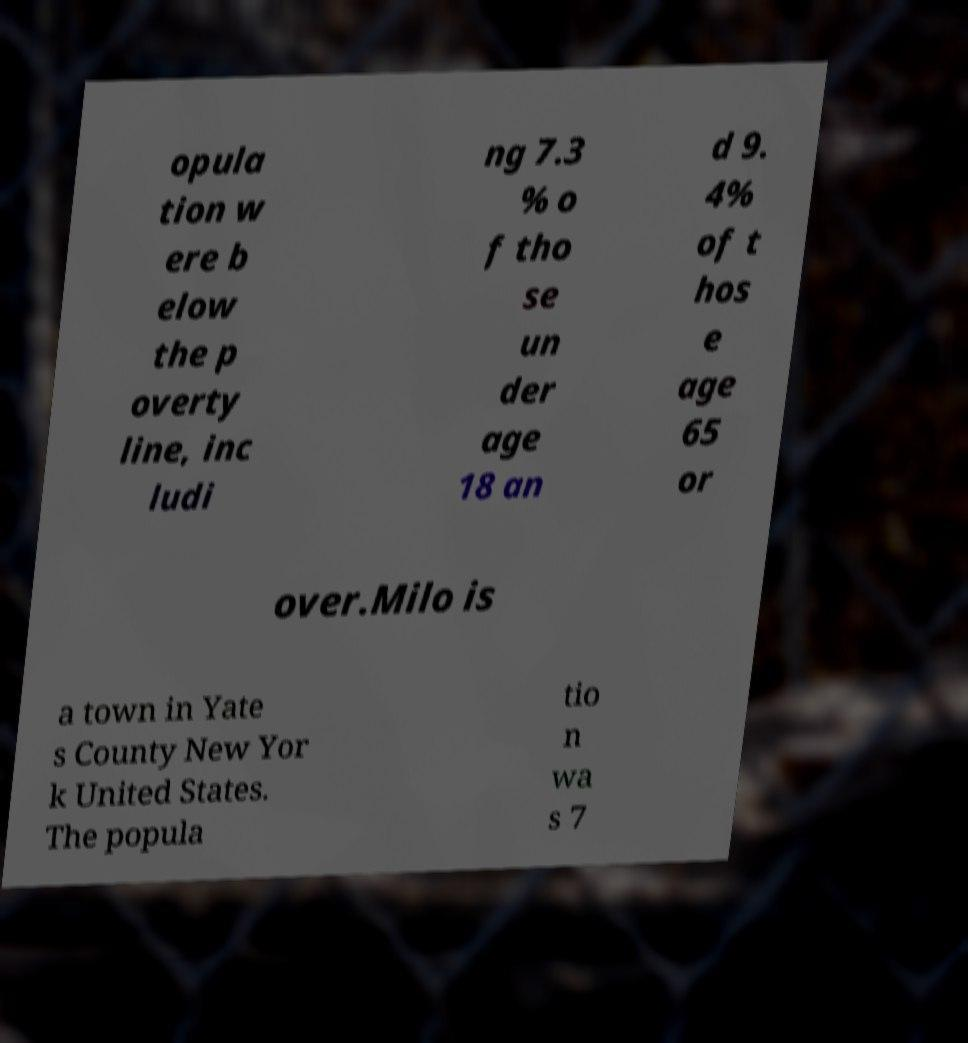Could you extract and type out the text from this image? opula tion w ere b elow the p overty line, inc ludi ng 7.3 % o f tho se un der age 18 an d 9. 4% of t hos e age 65 or over.Milo is a town in Yate s County New Yor k United States. The popula tio n wa s 7 